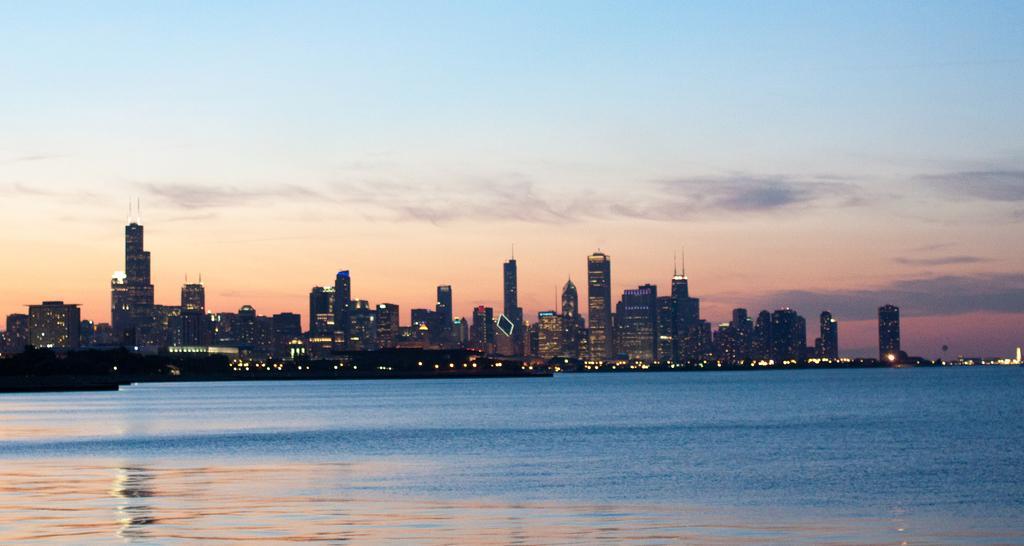Please provide a concise description of this image. In this picture we can see the lights, buildings, water and in the background we can see the sky with clouds. 